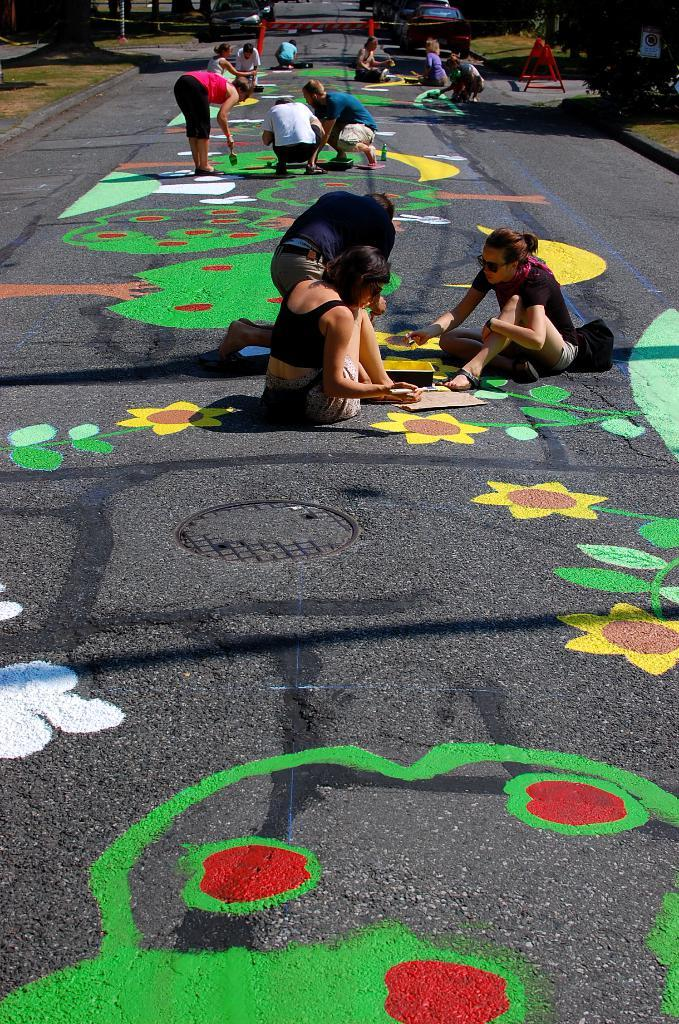What are the people in the image doing? The people in the image are painting. What are they painting on? They are painting flower designs on the road. How many paintings can be seen on the road? There are many paintings on the road. What can be seen in the background of the image? There are trees in the background of the image. Where are the trees located in relation to the road? The trees are beside the road. What type of stitch is being used to sew the boys' clothes in the image? There are no boys or clothes being sewn in the image; it features people painting flower designs on the road. Can you read the note that the person is holding in the image? There is no note present in the image. 